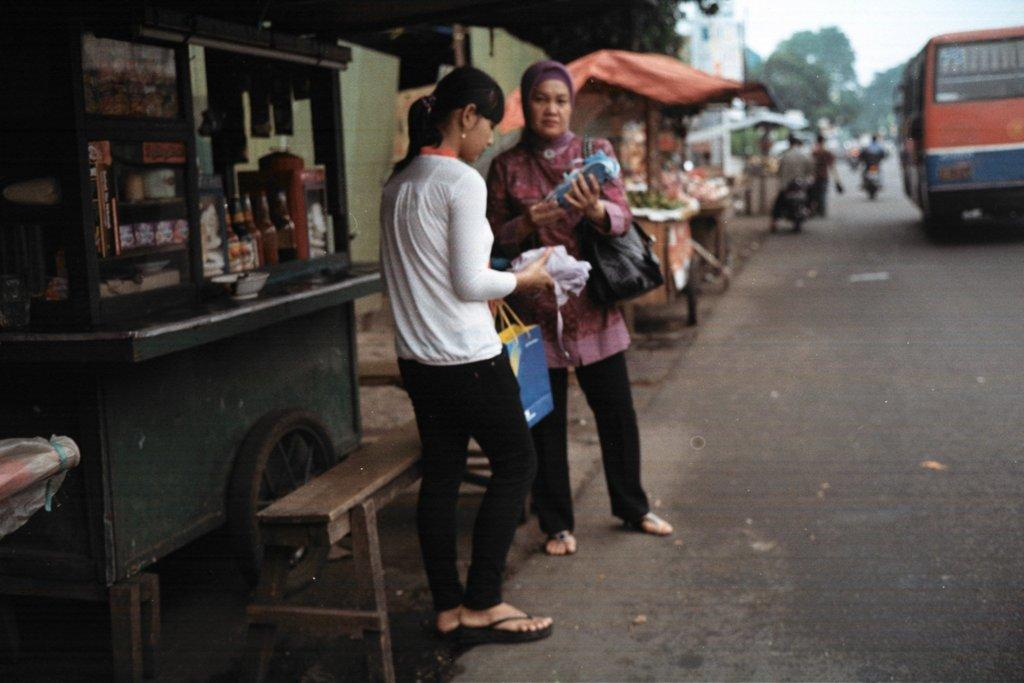How many people are standing on the road in the image? There are two persons standing on the road in the image. What is located on the left side of the image? There is a shop on the left side of the image. What can be seen on the right side of the image? There is a bus and two motorcycles on the right side of the image. What type of punishment is being handed out to the number range in the image? There is no punishment or number range present in the image. 